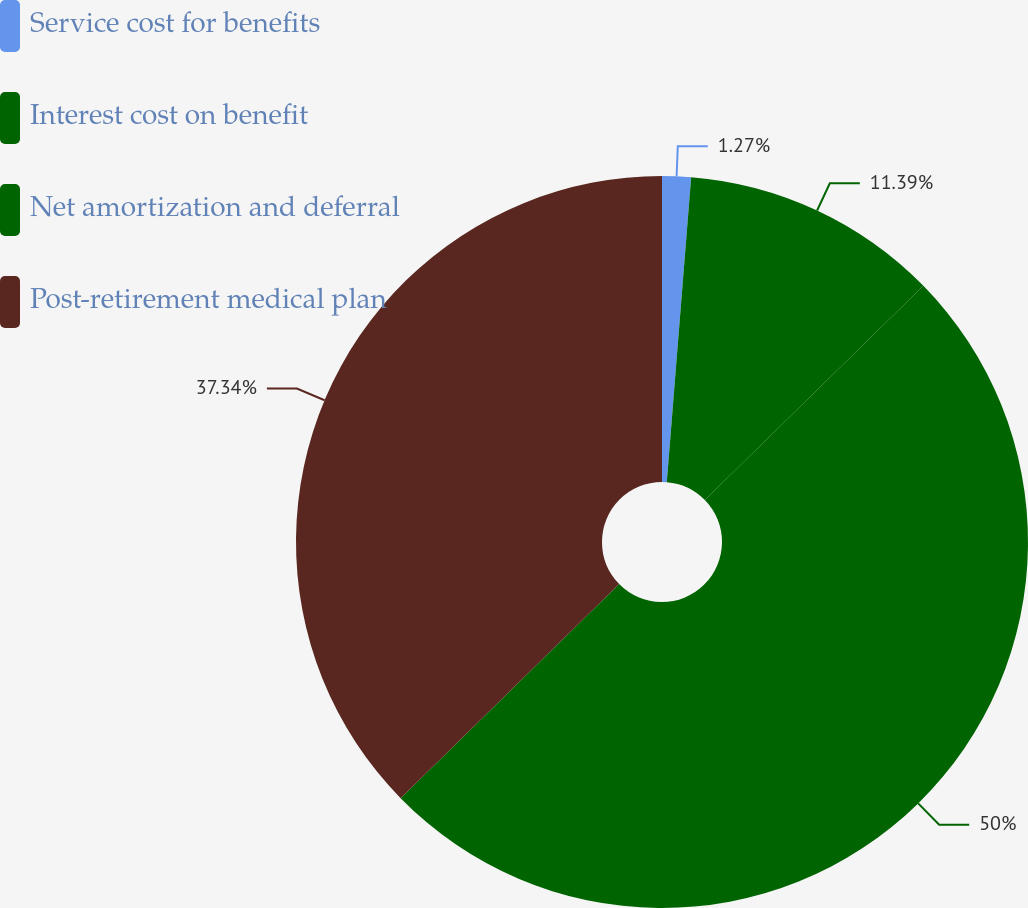Convert chart to OTSL. <chart><loc_0><loc_0><loc_500><loc_500><pie_chart><fcel>Service cost for benefits<fcel>Interest cost on benefit<fcel>Net amortization and deferral<fcel>Post-retirement medical plan<nl><fcel>1.27%<fcel>11.39%<fcel>50.0%<fcel>37.34%<nl></chart> 